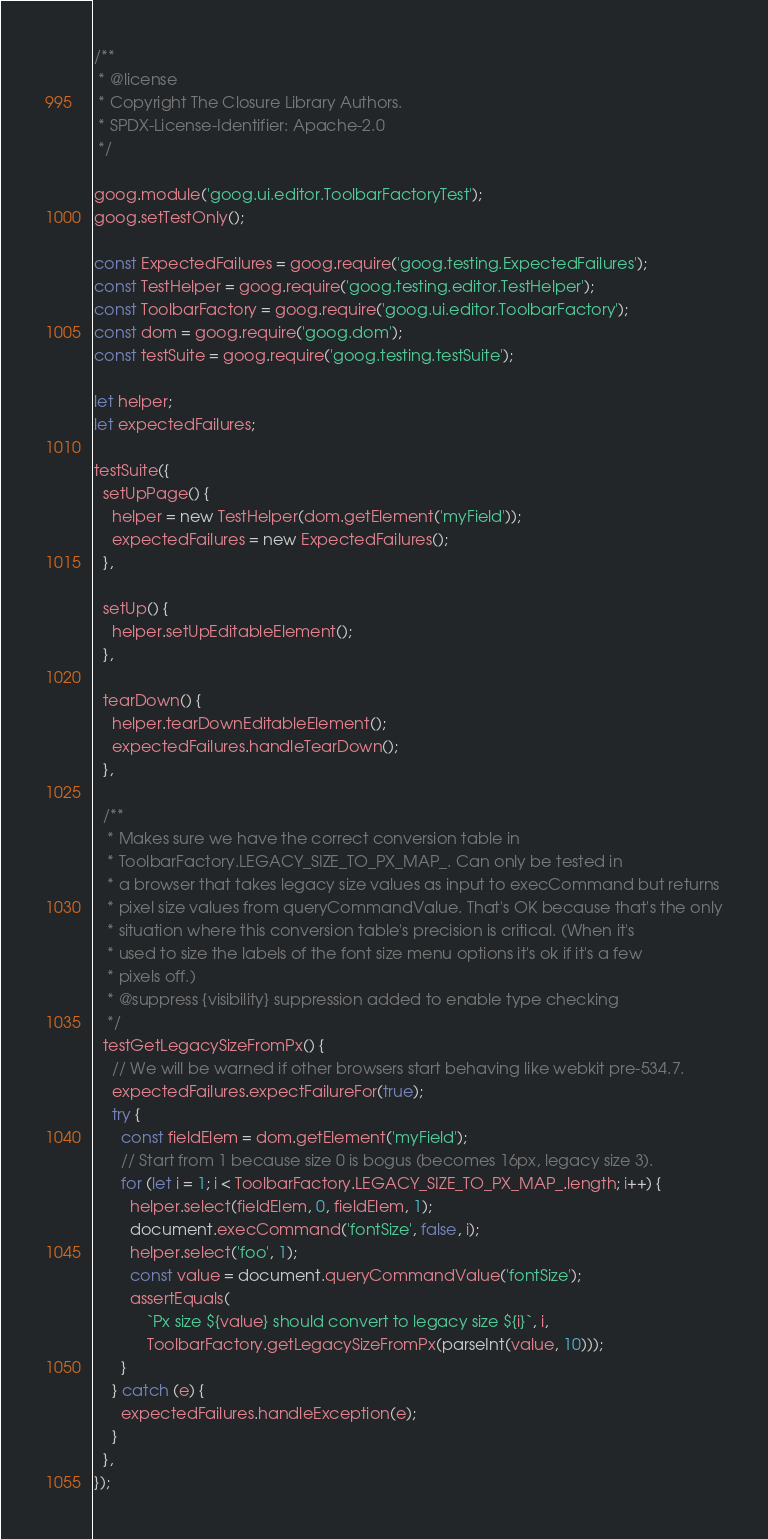Convert code to text. <code><loc_0><loc_0><loc_500><loc_500><_JavaScript_>/**
 * @license
 * Copyright The Closure Library Authors.
 * SPDX-License-Identifier: Apache-2.0
 */

goog.module('goog.ui.editor.ToolbarFactoryTest');
goog.setTestOnly();

const ExpectedFailures = goog.require('goog.testing.ExpectedFailures');
const TestHelper = goog.require('goog.testing.editor.TestHelper');
const ToolbarFactory = goog.require('goog.ui.editor.ToolbarFactory');
const dom = goog.require('goog.dom');
const testSuite = goog.require('goog.testing.testSuite');

let helper;
let expectedFailures;

testSuite({
  setUpPage() {
    helper = new TestHelper(dom.getElement('myField'));
    expectedFailures = new ExpectedFailures();
  },

  setUp() {
    helper.setUpEditableElement();
  },

  tearDown() {
    helper.tearDownEditableElement();
    expectedFailures.handleTearDown();
  },

  /**
   * Makes sure we have the correct conversion table in
   * ToolbarFactory.LEGACY_SIZE_TO_PX_MAP_. Can only be tested in
   * a browser that takes legacy size values as input to execCommand but returns
   * pixel size values from queryCommandValue. That's OK because that's the only
   * situation where this conversion table's precision is critical. (When it's
   * used to size the labels of the font size menu options it's ok if it's a few
   * pixels off.)
   * @suppress {visibility} suppression added to enable type checking
   */
  testGetLegacySizeFromPx() {
    // We will be warned if other browsers start behaving like webkit pre-534.7.
    expectedFailures.expectFailureFor(true);
    try {
      const fieldElem = dom.getElement('myField');
      // Start from 1 because size 0 is bogus (becomes 16px, legacy size 3).
      for (let i = 1; i < ToolbarFactory.LEGACY_SIZE_TO_PX_MAP_.length; i++) {
        helper.select(fieldElem, 0, fieldElem, 1);
        document.execCommand('fontSize', false, i);
        helper.select('foo', 1);
        const value = document.queryCommandValue('fontSize');
        assertEquals(
            `Px size ${value} should convert to legacy size ${i}`, i,
            ToolbarFactory.getLegacySizeFromPx(parseInt(value, 10)));
      }
    } catch (e) {
      expectedFailures.handleException(e);
    }
  },
});
</code> 